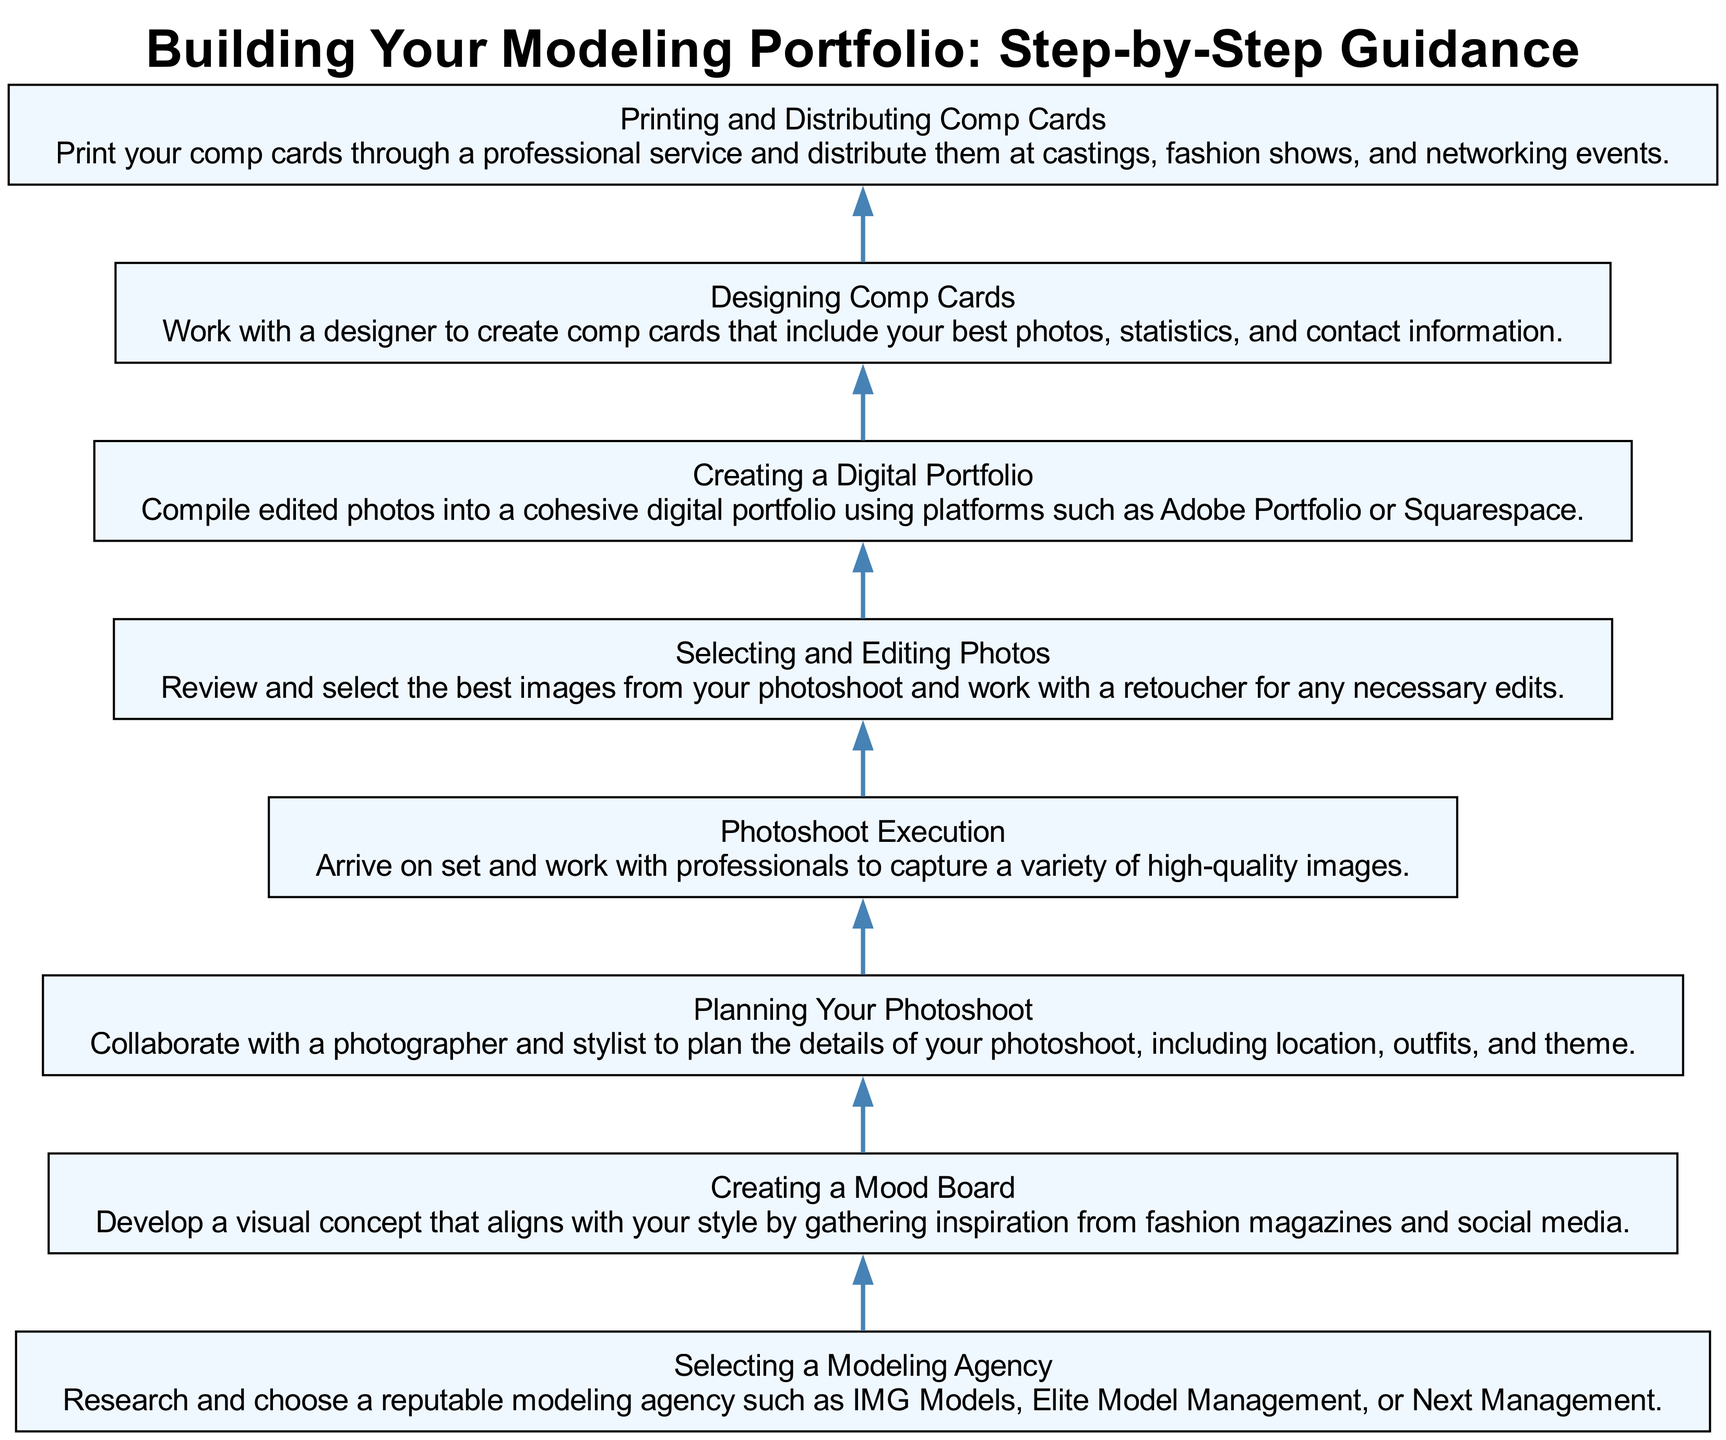What is the first step in building your modeling portfolio? The first step in the diagram is "Selecting a Modeling Agency," which is indicated at the bottom of the flow chart.
Answer: Selecting a Modeling Agency How many total steps are there in the diagram? By counting each of the nodes in the flow chart, there are eight distinct steps outlined for building a modeling portfolio.
Answer: Eight Which step comes immediately before "Designing Comp Cards"? The step that comes immediately before "Designing Comp Cards" is "Creating a Digital Portfolio," as indicated by the upward flow of the diagram.
Answer: Creating a Digital Portfolio What is required during the "Planning Your Photoshoot" step? In this step, the description specifies that collaboration with a photographer and stylist is necessary to plan various details for the photoshoot, such as location, outfits, and theme.
Answer: Collaboration with a photographer and stylist How does "Photoshoot Execution" relate to "Selecting and Editing Photos"? The flow chart indicates that "Photoshoot Execution" is completed first, leading to "Selecting and Editing Photos," indicating a sequential relationship where the execution must occur before image selection can happen.
Answer: Sequential relationship What platform can be used to create a digital portfolio? The description for "Creating a Digital Portfolio" mentions platforms like Adobe Portfolio or Squarespace, which are specifically chosen for this purpose.
Answer: Adobe Portfolio or Squarespace During the "Printing and Distributing Comp Cards" step, what is the main action taken? The main action taken in this step, as indicated in the description, is to print the comp cards and distribute them at relevant venues such as castings and fashion shows.
Answer: Print and distribute Which step focuses on visual concept development? The step dedicated to visual concept development is "Creating a Mood Board," where inspiration is gathered from fashion sources to align with the individual's style.
Answer: Creating a Mood Board 